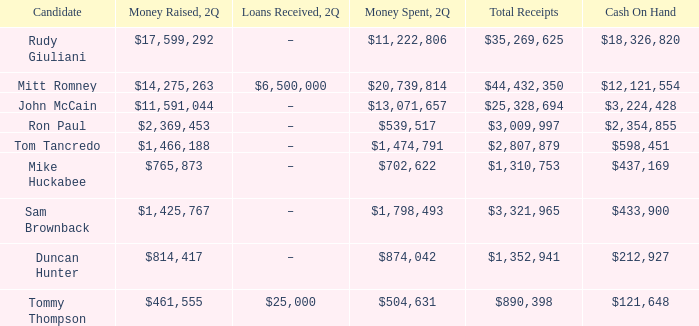Identify the loans that were granted in 2q, amounting to $25,328,694 in total receipts. –. 